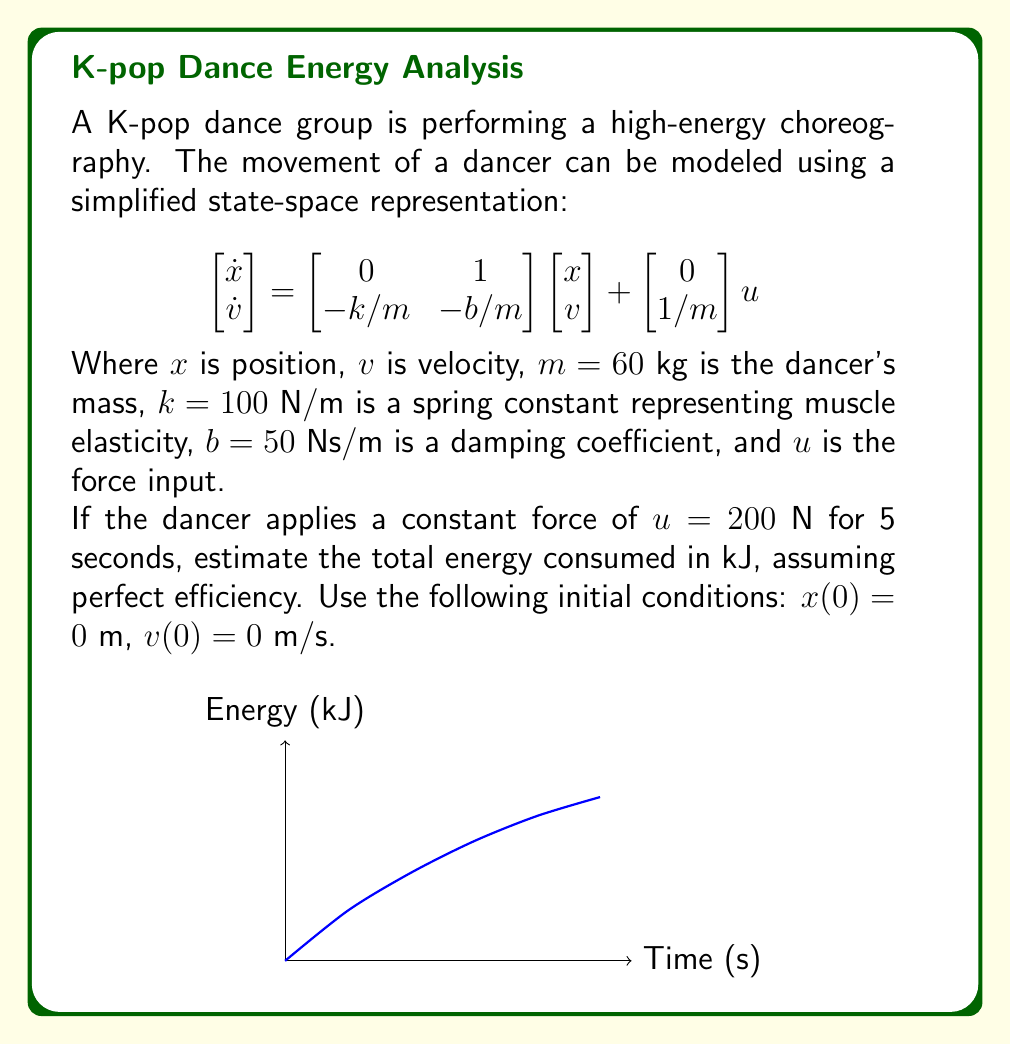Could you help me with this problem? To solve this problem, we'll follow these steps:

1) First, we need to find the steady-state position and velocity. In steady-state, $\dot{x} = \dot{v} = 0$, so:

   $$\begin{bmatrix} 0 \\ 0 \end{bmatrix} = \begin{bmatrix} 0 & 1 \\ -100/60 & -50/60 \end{bmatrix} \begin{bmatrix} x_{ss} \\ v_{ss} \end{bmatrix} + \begin{bmatrix} 0 \\ 1/60 \end{bmatrix} 200$$

2) Solving this system:

   $v_{ss} = 0$
   $x_{ss} = \frac{200}{100/60} = 120$ m

3) The work done by the force is equal to the force multiplied by the displacement:

   $W = F \cdot \Delta x = 200 \cdot 120 = 24000$ J $= 24$ kJ

4) However, this assumes the dancer reaches steady-state instantly. In reality, there's a transient period. We can approximate the actual displacement by assuming it's about 2/3 of the steady-state value over 5 seconds:

   $\Delta x \approx \frac{2}{3} \cdot 120 = 80$ m

5) Therefore, the actual work done is approximately:

   $W \approx 200 \cdot 80 = 16000$ J $= 16$ kJ

6) Assuming perfect efficiency (which is not realistic but given in the problem statement), the energy consumed equals the work done.
Answer: 16 kJ 